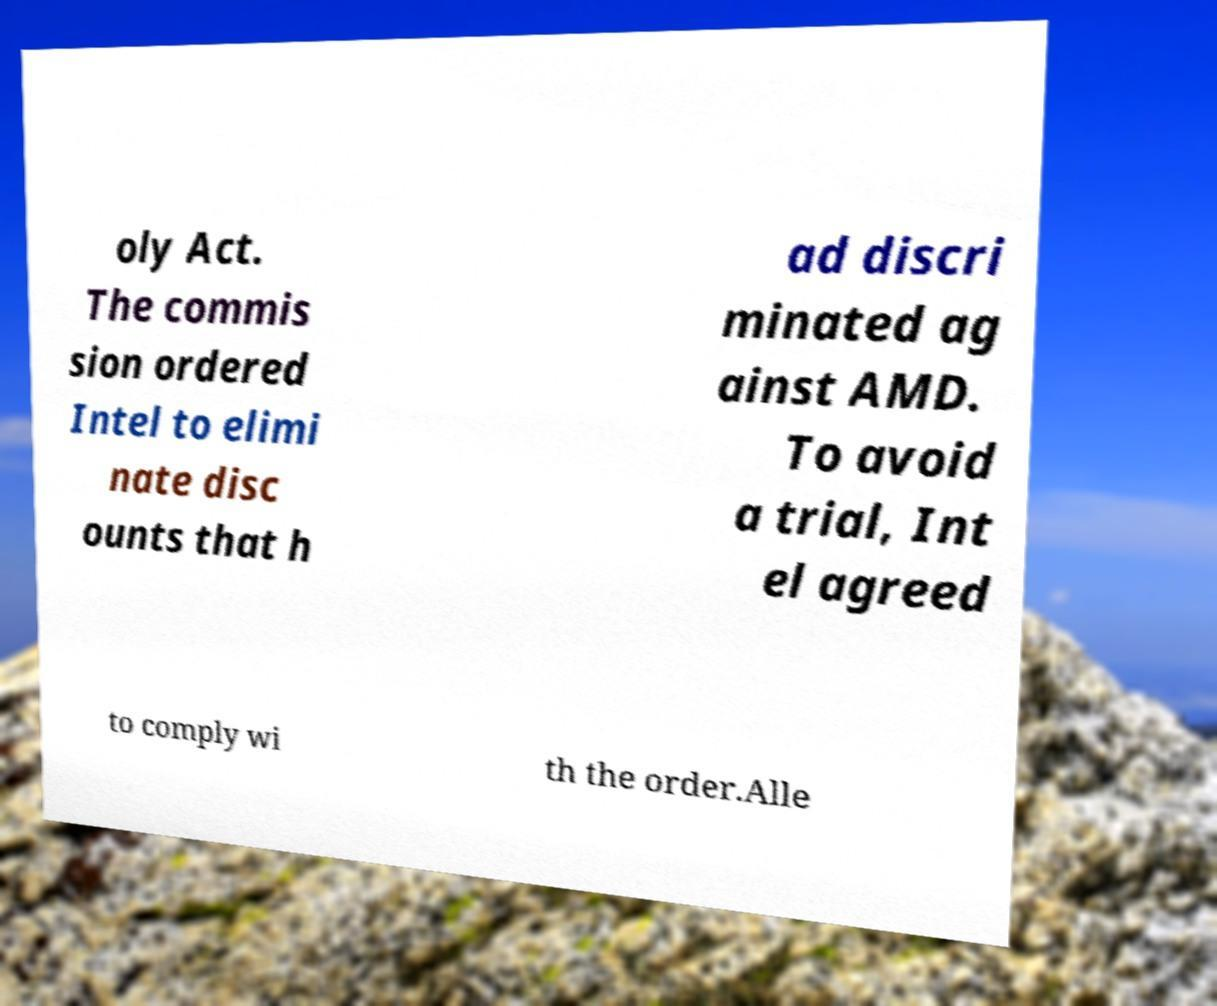For documentation purposes, I need the text within this image transcribed. Could you provide that? oly Act. The commis sion ordered Intel to elimi nate disc ounts that h ad discri minated ag ainst AMD. To avoid a trial, Int el agreed to comply wi th the order.Alle 